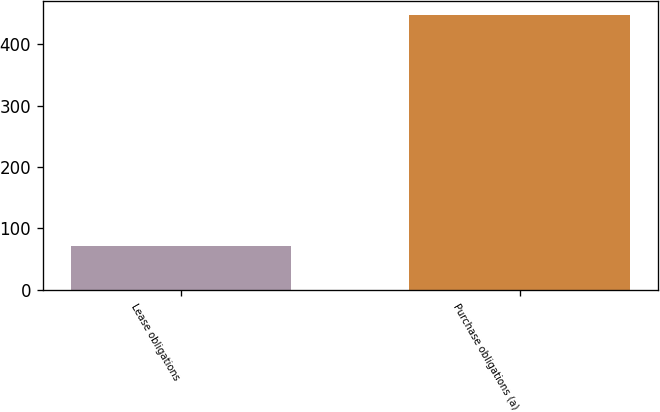<chart> <loc_0><loc_0><loc_500><loc_500><bar_chart><fcel>Lease obligations<fcel>Purchase obligations (a)<nl><fcel>72<fcel>447<nl></chart> 